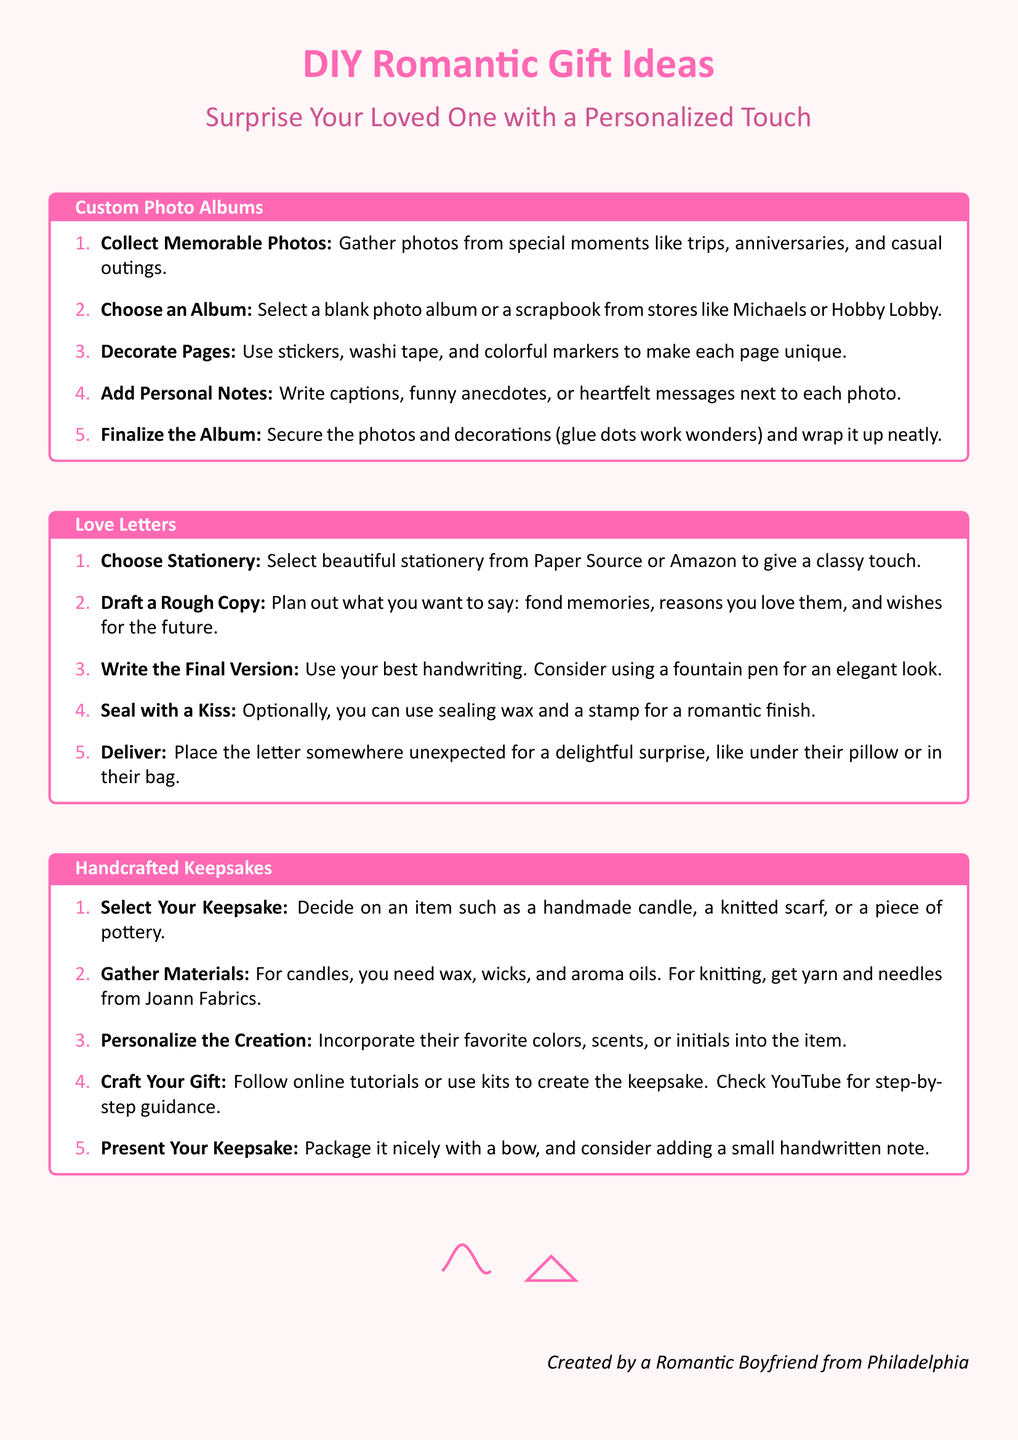What is the title of the flyer? The title of the flyer is displayed at the top of the document in a large font.
Answer: DIY Romantic Gift Ideas How many DIY gift ideas are presented in the flyer? The document lists three main ideas for DIY romantic gifts.
Answer: Three Where can you choose beautiful stationery for love letters? The document mentions specific stores where one can find stationery for writing love letters.
Answer: Paper Source or Amazon What is suggested to be used for sealing the love letter? The document provides a suggestion for a romantic finishing touch for the letter.
Answer: Sealing wax What should be included in the custom photo album? The steps include a specific type of note that enhances the personal touch of the album.
Answer: Personal notes Which crafting materials are required for handmade candles? The document lists essential materials needed to create specific types of handcrafted gifts.
Answer: Wax, wicks, aroma oils What is a recommended place to buy materials for knitting? The document points to a specific store that specializes in crafting materials for knitting projects.
Answer: Joann Fabrics In what city did the creator of the flyer claim to be from? The document includes a personal touch from the creator to connect with the audience.
Answer: Philadelphia 